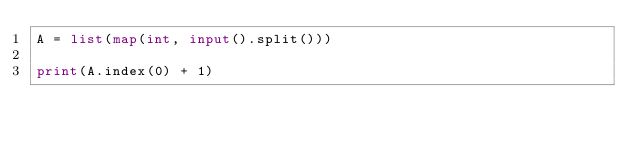<code> <loc_0><loc_0><loc_500><loc_500><_Python_>A = list(map(int, input().split()))

print(A.index(0) + 1)
</code> 